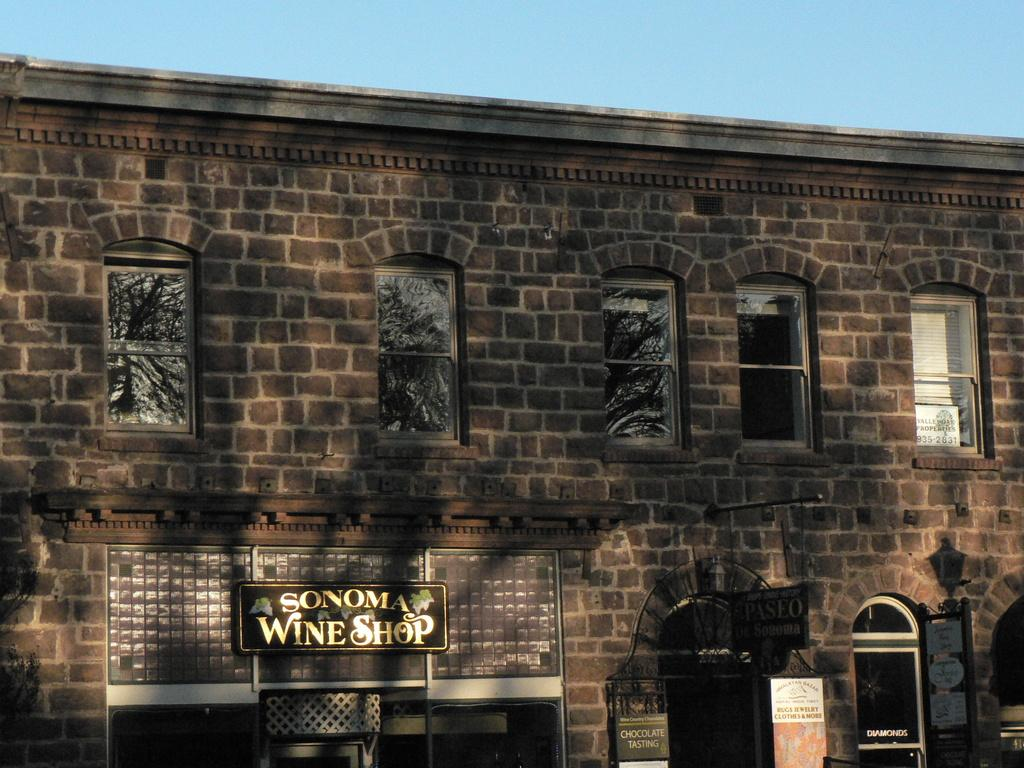<image>
Provide a brief description of the given image. An old brick building is home to a wine shop. 